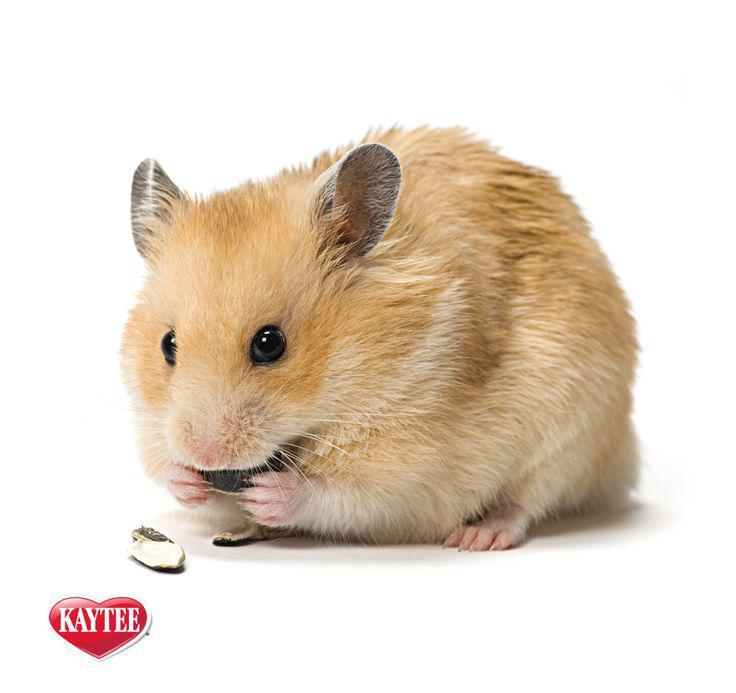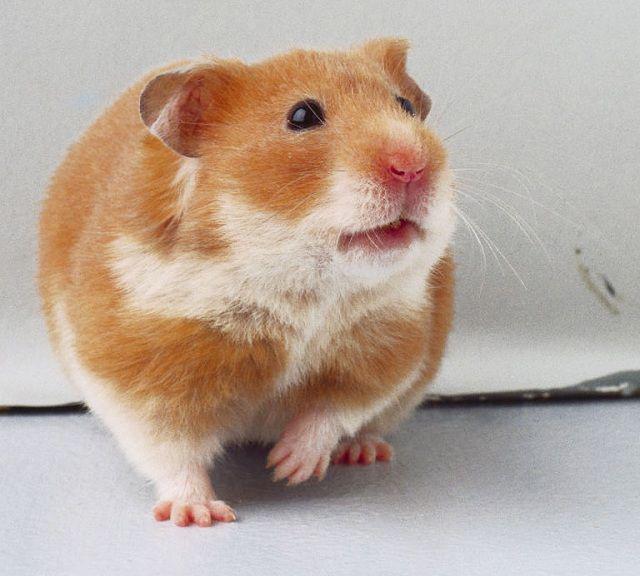The first image is the image on the left, the second image is the image on the right. Assess this claim about the two images: "The single hamster in one of the images has three feet on the floor and the other raised.". Correct or not? Answer yes or no. Yes. 